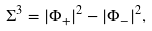<formula> <loc_0><loc_0><loc_500><loc_500>\Sigma ^ { 3 } = | \Phi _ { + } | ^ { 2 } - | \Phi _ { - } | ^ { 2 } ,</formula> 